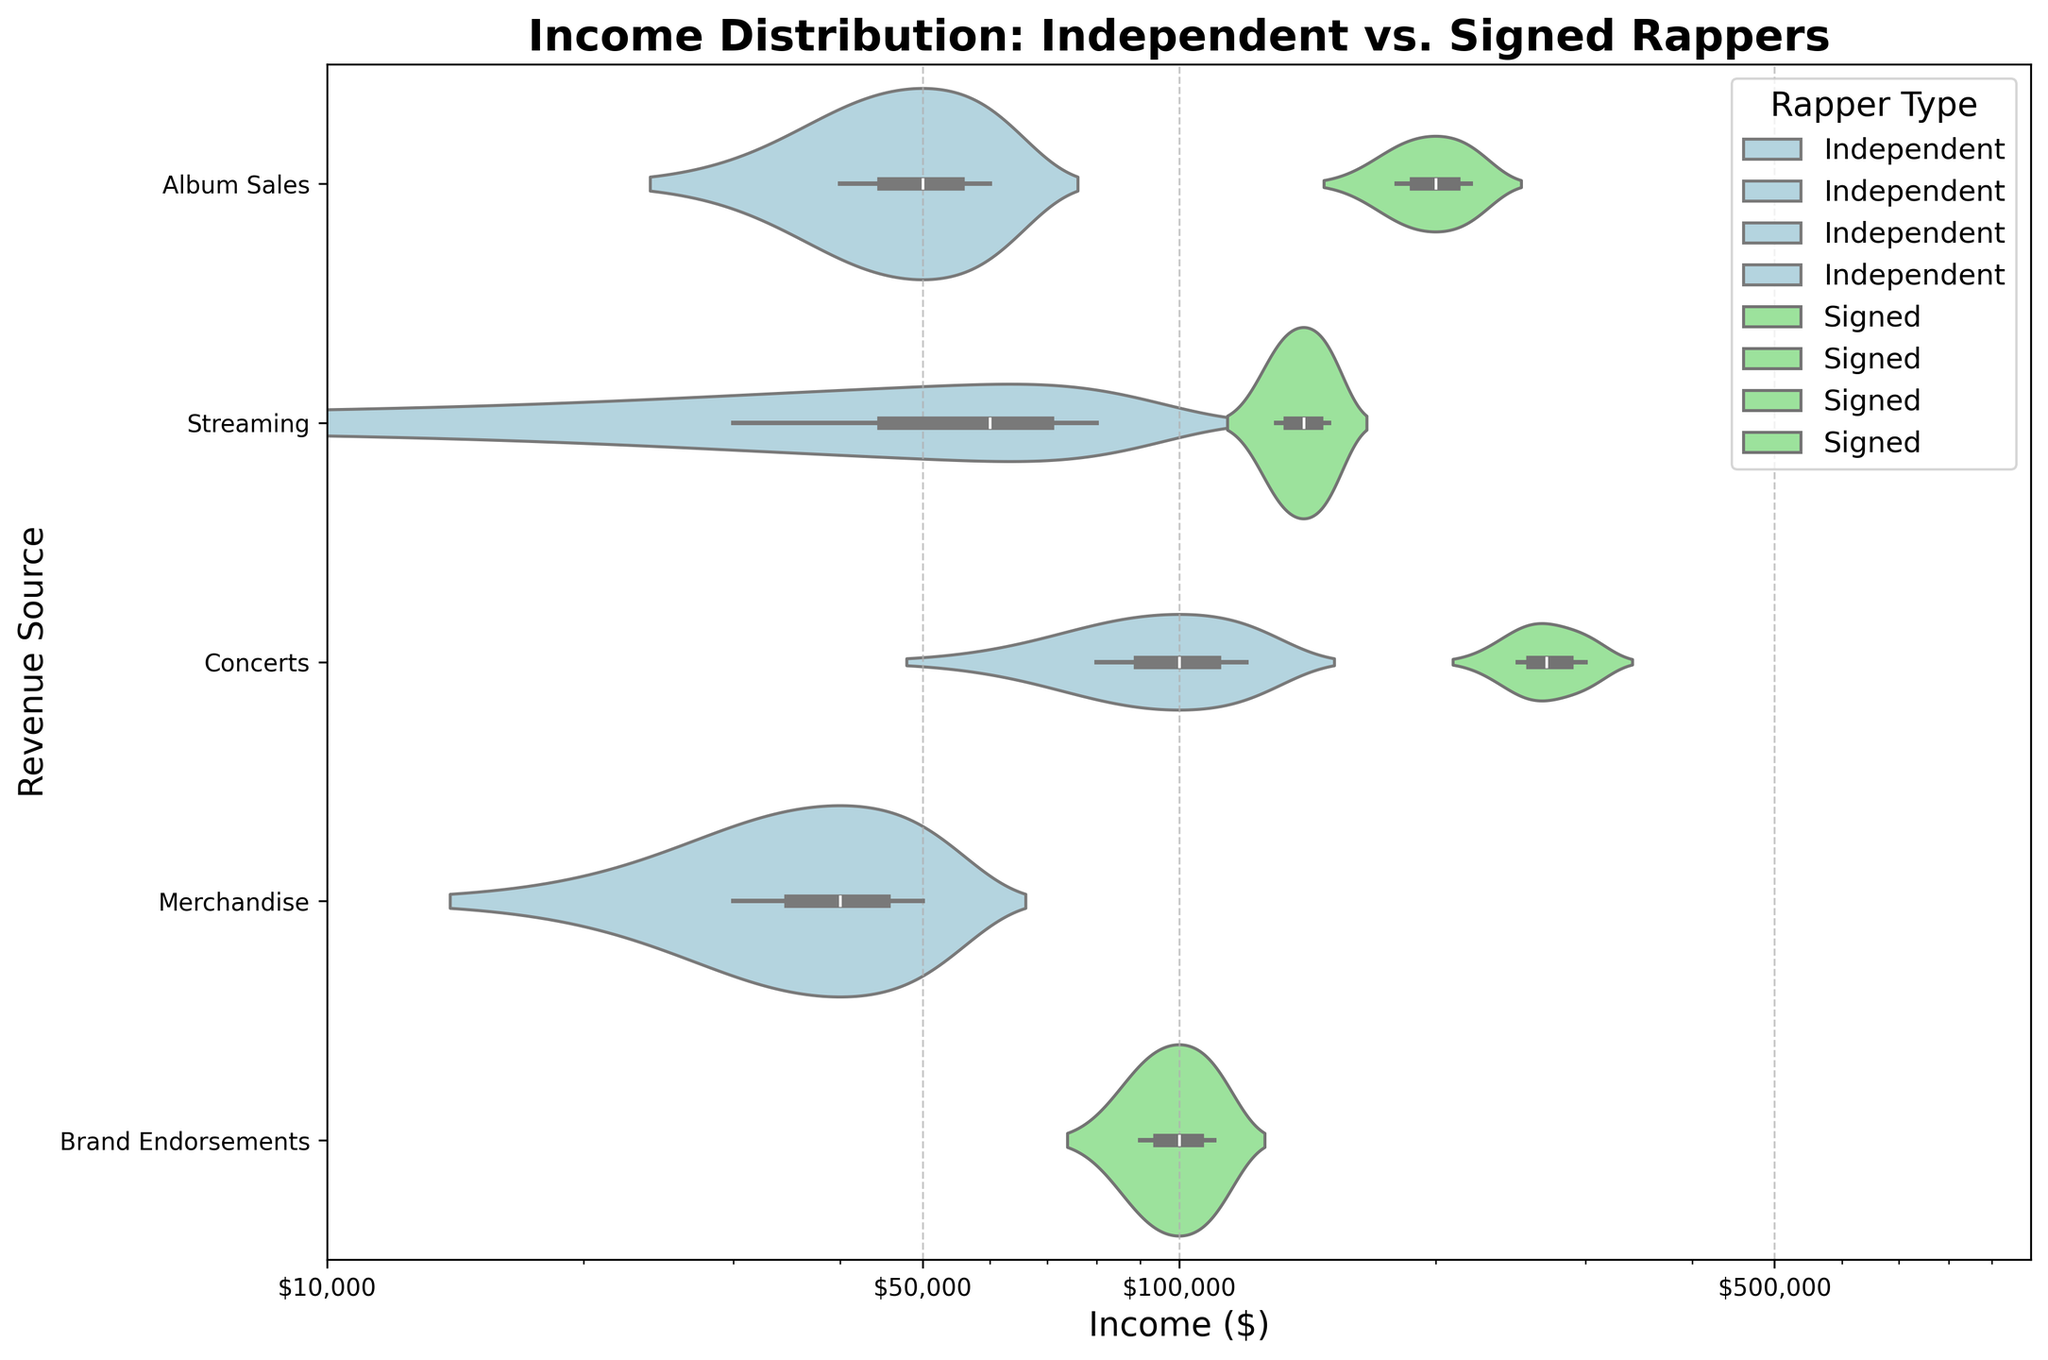What's the title of the chart? The title of the chart is displayed at the top center of the figure, making it easy to identify the main subject of the visualization.
Answer: Income Distribution: Independent vs. Signed Rappers What are the labels on the x-axis and y-axis? The x-axis label is found at the bottom of the chart, and the y-axis label is located on the left side. These labels describe the data dimensions being plotted.
Answer: The x-axis label is "Income ($)", and the y-axis label is "Revenue Source" What is the color used to represent the income distributions of independent rappers? Independent rappers' income distributions are represented by a distinct color on the chart.
Answer: Light blue Which revenue source has the widest income distribution for signed rappers? To determine this, observe the violin plots for signed rappers (light green) across different revenue sources and identify the one with the widest distribution.
Answer: Concerts Which rapper type has a greater income range from merchandise: independent or signed? Compare the width of the light blue and light green violin plots under the "Merchandise" revenue source to determine which has a wider range.
Answer: Independent For signed rappers, what is the approximate median income from streaming? Look at the center of the light green violin plot for "Streaming" to estimate the median, considering the log scale on the x-axis.
Answer: Around $150,000 Compare the highest income values for album sales between independent and signed rappers. Observe the maximum points on the light blue and light green violin plots for "Album Sales" and compare their values.
Answer: Signed rappers have a higher income Is the income distribution for concert revenues more varied among independent or signed rappers? Examine the spread and shape of the violin plots for "Concerts" for both light blue (independent) and light green (signed) to determine which shows more variability.
Answer: Signed rappers What does the x-axis log scale indicate about the income differences? A log scale on the x-axis is used to better visualize large differences in income by compressing large values and expanding small values.
Answer: It indicates considerable income differences across revenue sources and rapper types How many revenue sources are displayed for signed rappers in the chart? Count the distinct categories on the y-axis that have light green violin plots representing signed rappers.
Answer: Four 